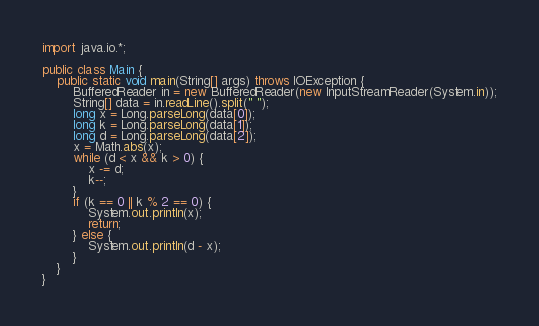<code> <loc_0><loc_0><loc_500><loc_500><_Java_>import java.io.*;

public class Main {
    public static void main(String[] args) throws IOException {
        BufferedReader in = new BufferedReader(new InputStreamReader(System.in));
        String[] data = in.readLine().split(" ");
        long x = Long.parseLong(data[0]);
        long k = Long.parseLong(data[1]);
        long d = Long.parseLong(data[2]);
        x = Math.abs(x);
        while (d < x && k > 0) {
            x -= d;
            k--;
        }
        if (k == 0 || k % 2 == 0) {
            System.out.println(x);
            return;
        } else {
            System.out.println(d - x);
        }
    }
}
</code> 